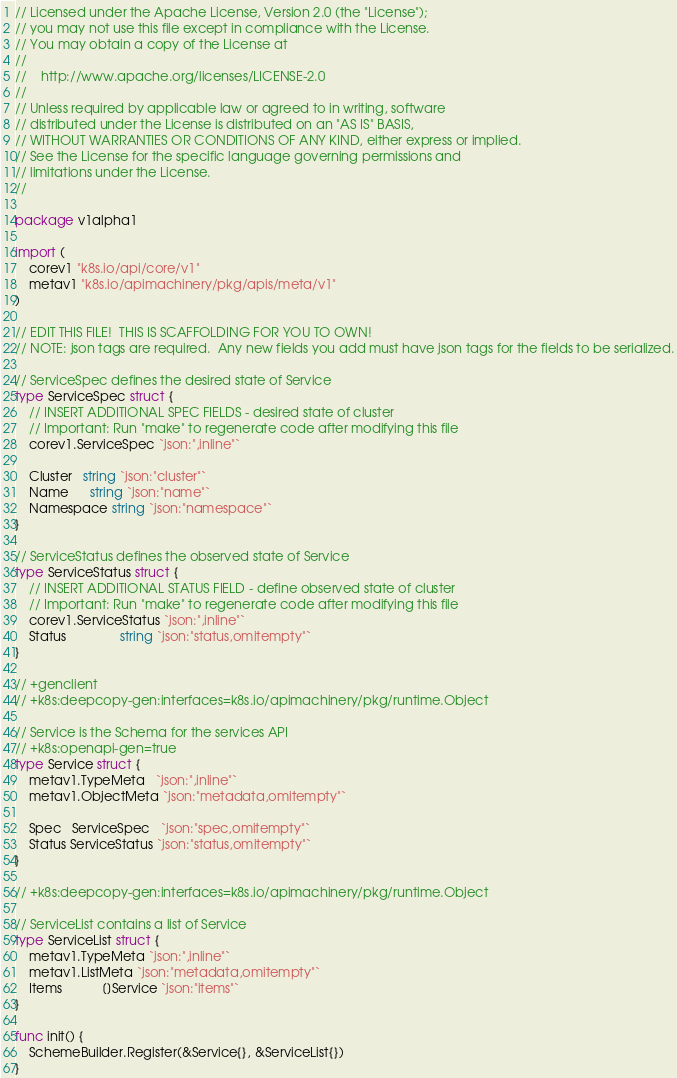Convert code to text. <code><loc_0><loc_0><loc_500><loc_500><_Go_>// Licensed under the Apache License, Version 2.0 (the "License");
// you may not use this file except in compliance with the License.
// You may obtain a copy of the License at
//
//    http://www.apache.org/licenses/LICENSE-2.0
//
// Unless required by applicable law or agreed to in writing, software
// distributed under the License is distributed on an "AS IS" BASIS,
// WITHOUT WARRANTIES OR CONDITIONS OF ANY KIND, either express or implied.
// See the License for the specific language governing permissions and
// limitations under the License.
//

package v1alpha1

import (
	corev1 "k8s.io/api/core/v1"
	metav1 "k8s.io/apimachinery/pkg/apis/meta/v1"
)

// EDIT THIS FILE!  THIS IS SCAFFOLDING FOR YOU TO OWN!
// NOTE: json tags are required.  Any new fields you add must have json tags for the fields to be serialized.

// ServiceSpec defines the desired state of Service
type ServiceSpec struct {
	// INSERT ADDITIONAL SPEC FIELDS - desired state of cluster
	// Important: Run "make" to regenerate code after modifying this file
	corev1.ServiceSpec `json:",inline"`

	Cluster   string `json:"cluster"`
	Name      string `json:"name"`
	Namespace string `json:"namespace"`
}

// ServiceStatus defines the observed state of Service
type ServiceStatus struct {
	// INSERT ADDITIONAL STATUS FIELD - define observed state of cluster
	// Important: Run "make" to regenerate code after modifying this file
	corev1.ServiceStatus `json:",inline"`
	Status               string `json:"status,omitempty"`
}

// +genclient
// +k8s:deepcopy-gen:interfaces=k8s.io/apimachinery/pkg/runtime.Object

// Service is the Schema for the services API
// +k8s:openapi-gen=true
type Service struct {
	metav1.TypeMeta   `json:",inline"`
	metav1.ObjectMeta `json:"metadata,omitempty"`

	Spec   ServiceSpec   `json:"spec,omitempty"`
	Status ServiceStatus `json:"status,omitempty"`
}

// +k8s:deepcopy-gen:interfaces=k8s.io/apimachinery/pkg/runtime.Object

// ServiceList contains a list of Service
type ServiceList struct {
	metav1.TypeMeta `json:",inline"`
	metav1.ListMeta `json:"metadata,omitempty"`
	Items           []Service `json:"items"`
}

func init() {
	SchemeBuilder.Register(&Service{}, &ServiceList{})
}
</code> 